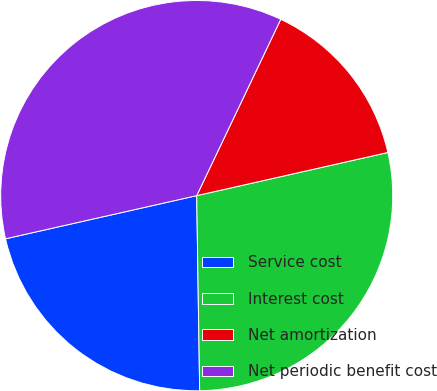Convert chart to OTSL. <chart><loc_0><loc_0><loc_500><loc_500><pie_chart><fcel>Service cost<fcel>Interest cost<fcel>Net amortization<fcel>Net periodic benefit cost<nl><fcel>21.69%<fcel>28.31%<fcel>14.4%<fcel>35.6%<nl></chart> 